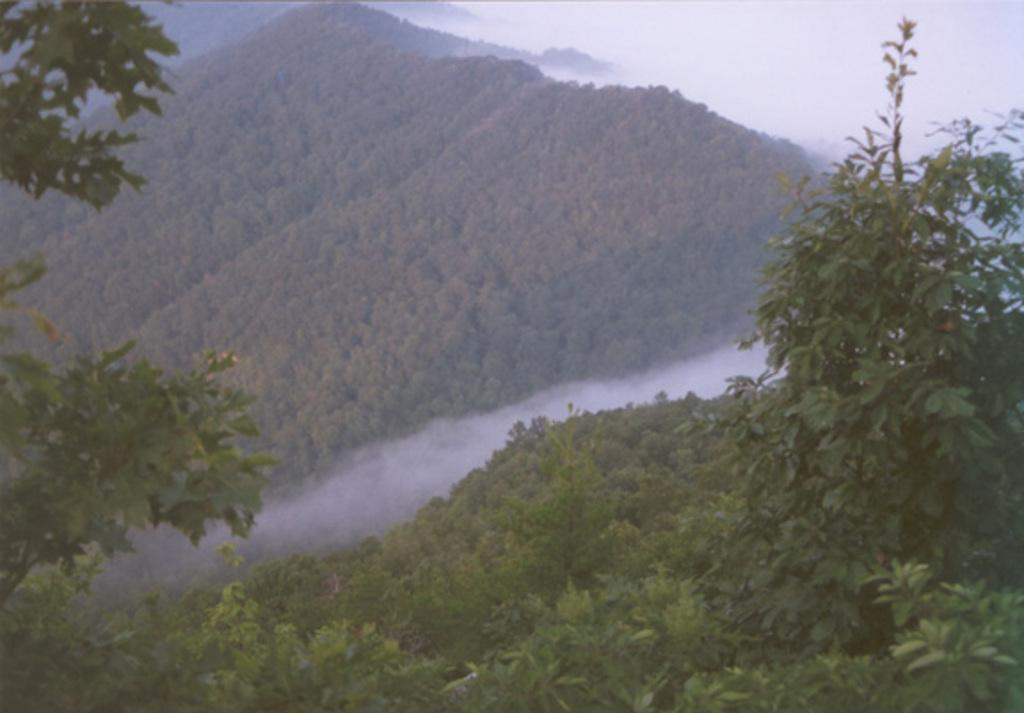What type of vegetation can be seen in the image? There are trees in the image. What can be seen in the sky in the image? There are clouds in the image. Are there any fairies visible among the trees in the image? There are no fairies present in the image; it only features trees and clouds. What type of expansion can be seen in the image? There is no expansion visible in the image; it only contains trees and clouds. 